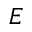Convert formula to latex. <formula><loc_0><loc_0><loc_500><loc_500>E</formula> 